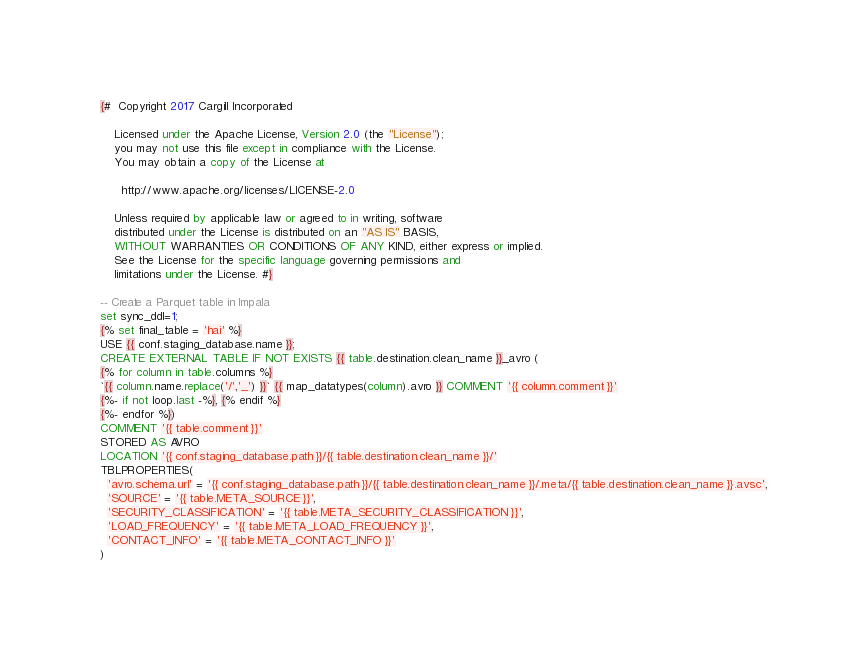Convert code to text. <code><loc_0><loc_0><loc_500><loc_500><_SQL_>{#  Copyright 2017 Cargill Incorporated

    Licensed under the Apache License, Version 2.0 (the "License");
    you may not use this file except in compliance with the License.
    You may obtain a copy of the License at

      http://www.apache.org/licenses/LICENSE-2.0

    Unless required by applicable law or agreed to in writing, software
    distributed under the License is distributed on an "AS IS" BASIS,
    WITHOUT WARRANTIES OR CONDITIONS OF ANY KIND, either express or implied.
    See the License for the specific language governing permissions and
    limitations under the License. #}

-- Create a Parquet table in Impala
set sync_ddl=1;
{% set final_table = 'hai' %}
USE {{ conf.staging_database.name }};
CREATE EXTERNAL TABLE IF NOT EXISTS {{ table.destination.clean_name }}_avro (
{% for column in table.columns %}
`{{ column.name.replace('/','_') }}` {{ map_datatypes(column).avro }} COMMENT '{{ column.comment }}'
{%- if not loop.last -%}, {% endif %}
{%- endfor %})
COMMENT '{{ table.comment }}'
STORED AS AVRO
LOCATION '{{ conf.staging_database.path }}/{{ table.destination.clean_name }}/'
TBLPROPERTIES(
  'avro.schema.url' = '{{ conf.staging_database.path }}/{{ table.destination.clean_name }}/.meta/{{ table.destination.clean_name }}.avsc',
  'SOURCE' = '{{ table.META_SOURCE }}',
  'SECURITY_CLASSIFICATION' = '{{ table.META_SECURITY_CLASSIFICATION }}',
  'LOAD_FREQUENCY' = '{{ table.META_LOAD_FREQUENCY }}',
  'CONTACT_INFO' = '{{ table.META_CONTACT_INFO }}'
)
</code> 